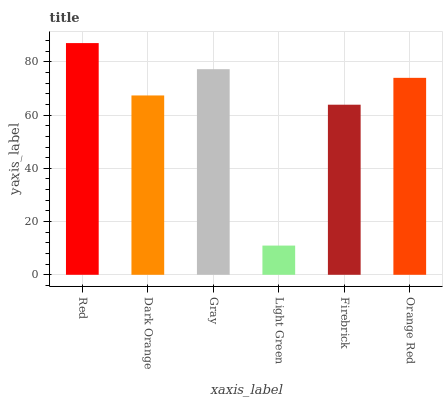Is Light Green the minimum?
Answer yes or no. Yes. Is Red the maximum?
Answer yes or no. Yes. Is Dark Orange the minimum?
Answer yes or no. No. Is Dark Orange the maximum?
Answer yes or no. No. Is Red greater than Dark Orange?
Answer yes or no. Yes. Is Dark Orange less than Red?
Answer yes or no. Yes. Is Dark Orange greater than Red?
Answer yes or no. No. Is Red less than Dark Orange?
Answer yes or no. No. Is Orange Red the high median?
Answer yes or no. Yes. Is Dark Orange the low median?
Answer yes or no. Yes. Is Firebrick the high median?
Answer yes or no. No. Is Orange Red the low median?
Answer yes or no. No. 